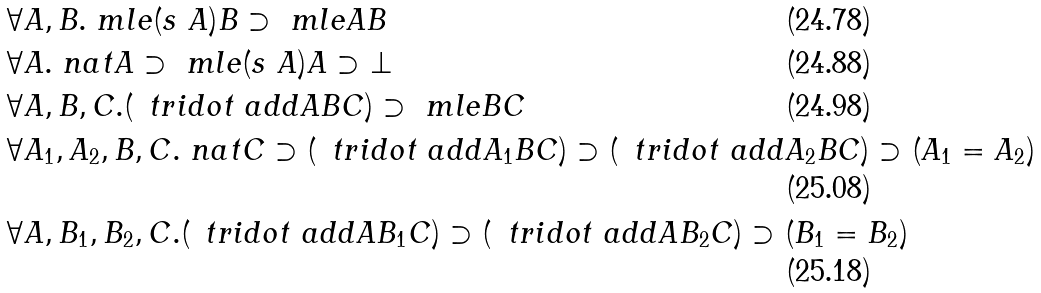<formula> <loc_0><loc_0><loc_500><loc_500>& \forall A , B . \ m l e { ( s \ A ) } B \supset \ m l e A B \\ & \forall A . \ n a t A \supset \ m l e { ( s \ A ) } A \supset \bot \\ & \forall A , B , C . ( \, \ t r i d o t \ a d d A B C ) \supset \ m l e B C \\ & \forall A _ { 1 } , A _ { 2 } , B , C . \ n a t C \supset ( \, \ t r i d o t \ a d d { A _ { 1 } } B C ) \supset ( \, \ t r i d o t \ a d d { A _ { 2 } } B C ) \supset ( A _ { 1 } = A _ { 2 } ) \\ & \forall A , B _ { 1 } , B _ { 2 } , C . ( \, \ t r i d o t \ a d d A { B _ { 1 } } C ) \supset ( \, \ t r i d o t \ a d d A { B _ { 2 } } C ) \supset ( B _ { 1 } = B _ { 2 } )</formula> 